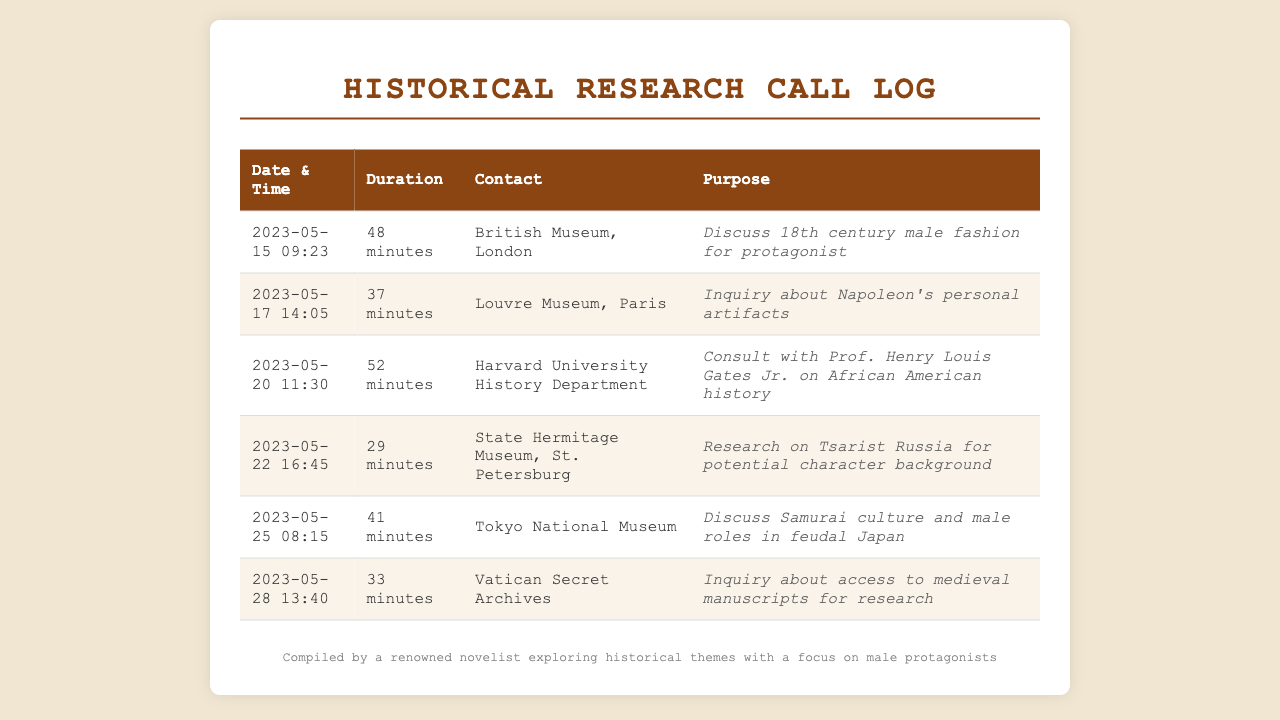What was the longest call duration? The call duration with the longest time is located in the table and is 52 minutes.
Answer: 52 minutes Who was the contact for the call on May 25? The contact for the call made on May 25 is listed as Tokyo National Museum.
Answer: Tokyo National Museum What purpose was discussed during the call with the British Museum? The purpose of the call with the British Museum involves 18th century male fashion for protagonist.
Answer: Discuss 18th century male fashion for protagonist Which museum was contacted last in the log? The last call in the log is with the Vatican Secret Archives on May 28.
Answer: Vatican Secret Archives How many minutes was the call to Harvard University History Department? The duration for the call to Harvard University History Department is noted in the document as 52 minutes.
Answer: 52 minutes What location did the call on May 22 pertain to? The call on May 22 was directed towards the State Hermitage Museum, St. Petersburg.
Answer: State Hermitage Museum, St. Petersburg What was the main inquiry in the call to the Vatican Secret Archives? The inquiry during the call to the Vatican Secret Archives was regarding access to medieval manuscripts for research.
Answer: Inquiry about access to medieval manuscripts for research What is the common theme of the calls made in the log? The calls made in the log focus on historical research, specifically male protagonists in various contexts.
Answer: Historical research on male protagonists 